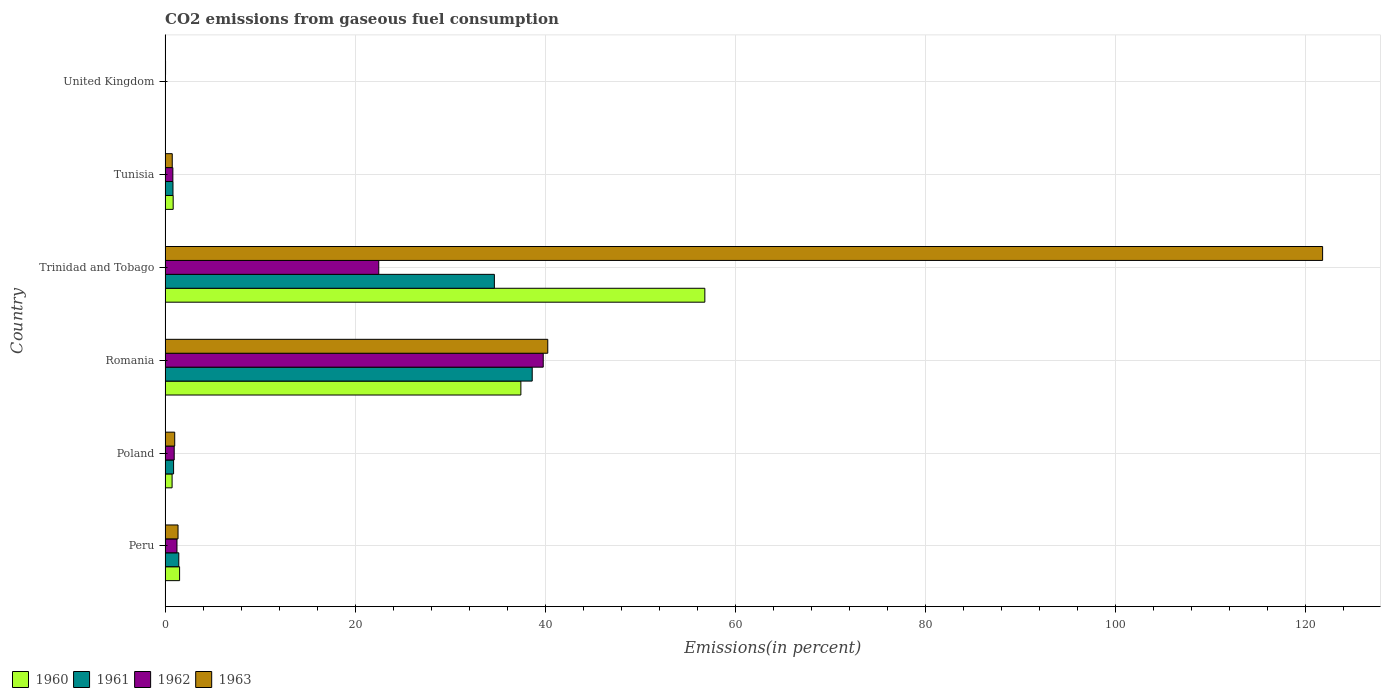How many groups of bars are there?
Your answer should be very brief. 6. How many bars are there on the 2nd tick from the top?
Offer a very short reply. 4. How many bars are there on the 4th tick from the bottom?
Provide a short and direct response. 4. What is the label of the 4th group of bars from the top?
Ensure brevity in your answer.  Romania. In how many cases, is the number of bars for a given country not equal to the number of legend labels?
Ensure brevity in your answer.  0. What is the total CO2 emitted in 1962 in United Kingdom?
Give a very brief answer. 0.04. Across all countries, what is the maximum total CO2 emitted in 1961?
Your response must be concise. 38.65. Across all countries, what is the minimum total CO2 emitted in 1960?
Provide a succinct answer. 0.03. In which country was the total CO2 emitted in 1962 maximum?
Ensure brevity in your answer.  Romania. In which country was the total CO2 emitted in 1962 minimum?
Provide a short and direct response. United Kingdom. What is the total total CO2 emitted in 1960 in the graph?
Your answer should be very brief. 97.41. What is the difference between the total CO2 emitted in 1960 in Peru and that in Poland?
Your answer should be compact. 0.79. What is the difference between the total CO2 emitted in 1963 in United Kingdom and the total CO2 emitted in 1961 in Peru?
Offer a terse response. -1.39. What is the average total CO2 emitted in 1963 per country?
Your response must be concise. 27.55. What is the difference between the total CO2 emitted in 1960 and total CO2 emitted in 1962 in Tunisia?
Offer a very short reply. 0.03. In how many countries, is the total CO2 emitted in 1960 greater than 28 %?
Offer a very short reply. 2. What is the ratio of the total CO2 emitted in 1962 in Peru to that in Tunisia?
Provide a short and direct response. 1.53. Is the difference between the total CO2 emitted in 1960 in Tunisia and United Kingdom greater than the difference between the total CO2 emitted in 1962 in Tunisia and United Kingdom?
Your answer should be very brief. Yes. What is the difference between the highest and the second highest total CO2 emitted in 1962?
Provide a short and direct response. 17.31. What is the difference between the highest and the lowest total CO2 emitted in 1963?
Ensure brevity in your answer.  121.8. Is it the case that in every country, the sum of the total CO2 emitted in 1960 and total CO2 emitted in 1962 is greater than the sum of total CO2 emitted in 1963 and total CO2 emitted in 1961?
Make the answer very short. No. What does the 4th bar from the top in Peru represents?
Make the answer very short. 1960. How many bars are there?
Give a very brief answer. 24. How many countries are there in the graph?
Offer a very short reply. 6. Does the graph contain any zero values?
Your answer should be very brief. No. Does the graph contain grids?
Keep it short and to the point. Yes. How are the legend labels stacked?
Provide a succinct answer. Horizontal. What is the title of the graph?
Your answer should be very brief. CO2 emissions from gaseous fuel consumption. What is the label or title of the X-axis?
Offer a terse response. Emissions(in percent). What is the Emissions(in percent) in 1960 in Peru?
Offer a terse response. 1.53. What is the Emissions(in percent) of 1961 in Peru?
Provide a succinct answer. 1.44. What is the Emissions(in percent) of 1962 in Peru?
Provide a short and direct response. 1.25. What is the Emissions(in percent) of 1963 in Peru?
Ensure brevity in your answer.  1.36. What is the Emissions(in percent) in 1960 in Poland?
Your response must be concise. 0.74. What is the Emissions(in percent) in 1961 in Poland?
Your answer should be very brief. 0.89. What is the Emissions(in percent) in 1962 in Poland?
Provide a short and direct response. 0.96. What is the Emissions(in percent) in 1963 in Poland?
Provide a short and direct response. 1.01. What is the Emissions(in percent) of 1960 in Romania?
Give a very brief answer. 37.45. What is the Emissions(in percent) of 1961 in Romania?
Your answer should be very brief. 38.65. What is the Emissions(in percent) in 1962 in Romania?
Offer a very short reply. 39.8. What is the Emissions(in percent) of 1963 in Romania?
Your response must be concise. 40.28. What is the Emissions(in percent) in 1960 in Trinidad and Tobago?
Offer a very short reply. 56.82. What is the Emissions(in percent) of 1961 in Trinidad and Tobago?
Ensure brevity in your answer.  34.66. What is the Emissions(in percent) of 1962 in Trinidad and Tobago?
Provide a short and direct response. 22.49. What is the Emissions(in percent) of 1963 in Trinidad and Tobago?
Offer a very short reply. 121.85. What is the Emissions(in percent) in 1960 in Tunisia?
Your response must be concise. 0.85. What is the Emissions(in percent) of 1961 in Tunisia?
Your response must be concise. 0.83. What is the Emissions(in percent) of 1962 in Tunisia?
Your answer should be compact. 0.82. What is the Emissions(in percent) in 1963 in Tunisia?
Provide a succinct answer. 0.75. What is the Emissions(in percent) in 1960 in United Kingdom?
Keep it short and to the point. 0.03. What is the Emissions(in percent) in 1961 in United Kingdom?
Provide a short and direct response. 0.03. What is the Emissions(in percent) of 1962 in United Kingdom?
Provide a short and direct response. 0.04. What is the Emissions(in percent) of 1963 in United Kingdom?
Keep it short and to the point. 0.05. Across all countries, what is the maximum Emissions(in percent) in 1960?
Offer a very short reply. 56.82. Across all countries, what is the maximum Emissions(in percent) in 1961?
Your response must be concise. 38.65. Across all countries, what is the maximum Emissions(in percent) of 1962?
Offer a terse response. 39.8. Across all countries, what is the maximum Emissions(in percent) of 1963?
Your answer should be very brief. 121.85. Across all countries, what is the minimum Emissions(in percent) in 1960?
Offer a very short reply. 0.03. Across all countries, what is the minimum Emissions(in percent) of 1961?
Your answer should be very brief. 0.03. Across all countries, what is the minimum Emissions(in percent) in 1962?
Keep it short and to the point. 0.04. Across all countries, what is the minimum Emissions(in percent) of 1963?
Your answer should be compact. 0.05. What is the total Emissions(in percent) in 1960 in the graph?
Ensure brevity in your answer.  97.41. What is the total Emissions(in percent) of 1961 in the graph?
Provide a succinct answer. 76.5. What is the total Emissions(in percent) of 1962 in the graph?
Offer a very short reply. 65.36. What is the total Emissions(in percent) of 1963 in the graph?
Make the answer very short. 165.31. What is the difference between the Emissions(in percent) of 1960 in Peru and that in Poland?
Keep it short and to the point. 0.79. What is the difference between the Emissions(in percent) of 1961 in Peru and that in Poland?
Offer a terse response. 0.55. What is the difference between the Emissions(in percent) of 1962 in Peru and that in Poland?
Offer a terse response. 0.29. What is the difference between the Emissions(in percent) of 1963 in Peru and that in Poland?
Make the answer very short. 0.35. What is the difference between the Emissions(in percent) of 1960 in Peru and that in Romania?
Keep it short and to the point. -35.93. What is the difference between the Emissions(in percent) in 1961 in Peru and that in Romania?
Offer a terse response. -37.2. What is the difference between the Emissions(in percent) of 1962 in Peru and that in Romania?
Ensure brevity in your answer.  -38.55. What is the difference between the Emissions(in percent) in 1963 in Peru and that in Romania?
Make the answer very short. -38.92. What is the difference between the Emissions(in percent) in 1960 in Peru and that in Trinidad and Tobago?
Your response must be concise. -55.29. What is the difference between the Emissions(in percent) of 1961 in Peru and that in Trinidad and Tobago?
Offer a very short reply. -33.22. What is the difference between the Emissions(in percent) of 1962 in Peru and that in Trinidad and Tobago?
Provide a short and direct response. -21.24. What is the difference between the Emissions(in percent) of 1963 in Peru and that in Trinidad and Tobago?
Give a very brief answer. -120.49. What is the difference between the Emissions(in percent) of 1960 in Peru and that in Tunisia?
Keep it short and to the point. 0.68. What is the difference between the Emissions(in percent) in 1961 in Peru and that in Tunisia?
Your answer should be compact. 0.61. What is the difference between the Emissions(in percent) in 1962 in Peru and that in Tunisia?
Provide a short and direct response. 0.43. What is the difference between the Emissions(in percent) in 1963 in Peru and that in Tunisia?
Provide a succinct answer. 0.61. What is the difference between the Emissions(in percent) of 1960 in Peru and that in United Kingdom?
Provide a short and direct response. 1.5. What is the difference between the Emissions(in percent) in 1961 in Peru and that in United Kingdom?
Make the answer very short. 1.42. What is the difference between the Emissions(in percent) in 1962 in Peru and that in United Kingdom?
Ensure brevity in your answer.  1.21. What is the difference between the Emissions(in percent) of 1963 in Peru and that in United Kingdom?
Give a very brief answer. 1.31. What is the difference between the Emissions(in percent) in 1960 in Poland and that in Romania?
Make the answer very short. -36.72. What is the difference between the Emissions(in percent) of 1961 in Poland and that in Romania?
Provide a short and direct response. -37.75. What is the difference between the Emissions(in percent) of 1962 in Poland and that in Romania?
Give a very brief answer. -38.85. What is the difference between the Emissions(in percent) of 1963 in Poland and that in Romania?
Make the answer very short. -39.27. What is the difference between the Emissions(in percent) in 1960 in Poland and that in Trinidad and Tobago?
Ensure brevity in your answer.  -56.08. What is the difference between the Emissions(in percent) of 1961 in Poland and that in Trinidad and Tobago?
Offer a terse response. -33.77. What is the difference between the Emissions(in percent) in 1962 in Poland and that in Trinidad and Tobago?
Provide a short and direct response. -21.53. What is the difference between the Emissions(in percent) of 1963 in Poland and that in Trinidad and Tobago?
Keep it short and to the point. -120.84. What is the difference between the Emissions(in percent) of 1960 in Poland and that in Tunisia?
Your response must be concise. -0.11. What is the difference between the Emissions(in percent) of 1961 in Poland and that in Tunisia?
Provide a short and direct response. 0.06. What is the difference between the Emissions(in percent) of 1962 in Poland and that in Tunisia?
Make the answer very short. 0.14. What is the difference between the Emissions(in percent) of 1963 in Poland and that in Tunisia?
Provide a succinct answer. 0.26. What is the difference between the Emissions(in percent) in 1960 in Poland and that in United Kingdom?
Keep it short and to the point. 0.71. What is the difference between the Emissions(in percent) of 1961 in Poland and that in United Kingdom?
Provide a short and direct response. 0.87. What is the difference between the Emissions(in percent) of 1962 in Poland and that in United Kingdom?
Provide a short and direct response. 0.92. What is the difference between the Emissions(in percent) of 1963 in Poland and that in United Kingdom?
Keep it short and to the point. 0.97. What is the difference between the Emissions(in percent) in 1960 in Romania and that in Trinidad and Tobago?
Offer a terse response. -19.37. What is the difference between the Emissions(in percent) in 1961 in Romania and that in Trinidad and Tobago?
Offer a very short reply. 3.98. What is the difference between the Emissions(in percent) in 1962 in Romania and that in Trinidad and Tobago?
Offer a very short reply. 17.31. What is the difference between the Emissions(in percent) in 1963 in Romania and that in Trinidad and Tobago?
Your answer should be compact. -81.57. What is the difference between the Emissions(in percent) of 1960 in Romania and that in Tunisia?
Provide a short and direct response. 36.6. What is the difference between the Emissions(in percent) in 1961 in Romania and that in Tunisia?
Make the answer very short. 37.82. What is the difference between the Emissions(in percent) in 1962 in Romania and that in Tunisia?
Offer a very short reply. 38.99. What is the difference between the Emissions(in percent) of 1963 in Romania and that in Tunisia?
Offer a terse response. 39.53. What is the difference between the Emissions(in percent) of 1960 in Romania and that in United Kingdom?
Offer a terse response. 37.43. What is the difference between the Emissions(in percent) of 1961 in Romania and that in United Kingdom?
Keep it short and to the point. 38.62. What is the difference between the Emissions(in percent) of 1962 in Romania and that in United Kingdom?
Ensure brevity in your answer.  39.77. What is the difference between the Emissions(in percent) of 1963 in Romania and that in United Kingdom?
Your response must be concise. 40.23. What is the difference between the Emissions(in percent) in 1960 in Trinidad and Tobago and that in Tunisia?
Give a very brief answer. 55.97. What is the difference between the Emissions(in percent) in 1961 in Trinidad and Tobago and that in Tunisia?
Make the answer very short. 33.83. What is the difference between the Emissions(in percent) of 1962 in Trinidad and Tobago and that in Tunisia?
Your response must be concise. 21.68. What is the difference between the Emissions(in percent) of 1963 in Trinidad and Tobago and that in Tunisia?
Provide a short and direct response. 121.1. What is the difference between the Emissions(in percent) in 1960 in Trinidad and Tobago and that in United Kingdom?
Provide a succinct answer. 56.79. What is the difference between the Emissions(in percent) in 1961 in Trinidad and Tobago and that in United Kingdom?
Make the answer very short. 34.64. What is the difference between the Emissions(in percent) of 1962 in Trinidad and Tobago and that in United Kingdom?
Your answer should be very brief. 22.46. What is the difference between the Emissions(in percent) of 1963 in Trinidad and Tobago and that in United Kingdom?
Keep it short and to the point. 121.8. What is the difference between the Emissions(in percent) of 1960 in Tunisia and that in United Kingdom?
Your response must be concise. 0.82. What is the difference between the Emissions(in percent) of 1961 in Tunisia and that in United Kingdom?
Give a very brief answer. 0.8. What is the difference between the Emissions(in percent) of 1962 in Tunisia and that in United Kingdom?
Provide a succinct answer. 0.78. What is the difference between the Emissions(in percent) in 1963 in Tunisia and that in United Kingdom?
Provide a short and direct response. 0.71. What is the difference between the Emissions(in percent) of 1960 in Peru and the Emissions(in percent) of 1961 in Poland?
Your response must be concise. 0.63. What is the difference between the Emissions(in percent) in 1960 in Peru and the Emissions(in percent) in 1962 in Poland?
Your response must be concise. 0.57. What is the difference between the Emissions(in percent) of 1960 in Peru and the Emissions(in percent) of 1963 in Poland?
Give a very brief answer. 0.51. What is the difference between the Emissions(in percent) in 1961 in Peru and the Emissions(in percent) in 1962 in Poland?
Your response must be concise. 0.48. What is the difference between the Emissions(in percent) of 1961 in Peru and the Emissions(in percent) of 1963 in Poland?
Offer a very short reply. 0.43. What is the difference between the Emissions(in percent) in 1962 in Peru and the Emissions(in percent) in 1963 in Poland?
Your response must be concise. 0.24. What is the difference between the Emissions(in percent) of 1960 in Peru and the Emissions(in percent) of 1961 in Romania?
Ensure brevity in your answer.  -37.12. What is the difference between the Emissions(in percent) of 1960 in Peru and the Emissions(in percent) of 1962 in Romania?
Provide a short and direct response. -38.28. What is the difference between the Emissions(in percent) of 1960 in Peru and the Emissions(in percent) of 1963 in Romania?
Provide a succinct answer. -38.76. What is the difference between the Emissions(in percent) of 1961 in Peru and the Emissions(in percent) of 1962 in Romania?
Your answer should be compact. -38.36. What is the difference between the Emissions(in percent) in 1961 in Peru and the Emissions(in percent) in 1963 in Romania?
Ensure brevity in your answer.  -38.84. What is the difference between the Emissions(in percent) in 1962 in Peru and the Emissions(in percent) in 1963 in Romania?
Ensure brevity in your answer.  -39.03. What is the difference between the Emissions(in percent) of 1960 in Peru and the Emissions(in percent) of 1961 in Trinidad and Tobago?
Your answer should be compact. -33.14. What is the difference between the Emissions(in percent) of 1960 in Peru and the Emissions(in percent) of 1962 in Trinidad and Tobago?
Provide a short and direct response. -20.97. What is the difference between the Emissions(in percent) in 1960 in Peru and the Emissions(in percent) in 1963 in Trinidad and Tobago?
Your response must be concise. -120.32. What is the difference between the Emissions(in percent) in 1961 in Peru and the Emissions(in percent) in 1962 in Trinidad and Tobago?
Offer a terse response. -21.05. What is the difference between the Emissions(in percent) of 1961 in Peru and the Emissions(in percent) of 1963 in Trinidad and Tobago?
Make the answer very short. -120.41. What is the difference between the Emissions(in percent) in 1962 in Peru and the Emissions(in percent) in 1963 in Trinidad and Tobago?
Offer a terse response. -120.6. What is the difference between the Emissions(in percent) in 1960 in Peru and the Emissions(in percent) in 1961 in Tunisia?
Give a very brief answer. 0.7. What is the difference between the Emissions(in percent) of 1960 in Peru and the Emissions(in percent) of 1962 in Tunisia?
Your answer should be compact. 0.71. What is the difference between the Emissions(in percent) in 1960 in Peru and the Emissions(in percent) in 1963 in Tunisia?
Offer a very short reply. 0.77. What is the difference between the Emissions(in percent) of 1961 in Peru and the Emissions(in percent) of 1962 in Tunisia?
Offer a very short reply. 0.63. What is the difference between the Emissions(in percent) of 1961 in Peru and the Emissions(in percent) of 1963 in Tunisia?
Provide a succinct answer. 0.69. What is the difference between the Emissions(in percent) of 1962 in Peru and the Emissions(in percent) of 1963 in Tunisia?
Make the answer very short. 0.5. What is the difference between the Emissions(in percent) of 1960 in Peru and the Emissions(in percent) of 1961 in United Kingdom?
Your answer should be very brief. 1.5. What is the difference between the Emissions(in percent) in 1960 in Peru and the Emissions(in percent) in 1962 in United Kingdom?
Make the answer very short. 1.49. What is the difference between the Emissions(in percent) of 1960 in Peru and the Emissions(in percent) of 1963 in United Kingdom?
Provide a short and direct response. 1.48. What is the difference between the Emissions(in percent) of 1961 in Peru and the Emissions(in percent) of 1962 in United Kingdom?
Your response must be concise. 1.41. What is the difference between the Emissions(in percent) of 1961 in Peru and the Emissions(in percent) of 1963 in United Kingdom?
Keep it short and to the point. 1.39. What is the difference between the Emissions(in percent) in 1962 in Peru and the Emissions(in percent) in 1963 in United Kingdom?
Give a very brief answer. 1.2. What is the difference between the Emissions(in percent) in 1960 in Poland and the Emissions(in percent) in 1961 in Romania?
Your answer should be compact. -37.91. What is the difference between the Emissions(in percent) in 1960 in Poland and the Emissions(in percent) in 1962 in Romania?
Offer a terse response. -39.07. What is the difference between the Emissions(in percent) of 1960 in Poland and the Emissions(in percent) of 1963 in Romania?
Offer a terse response. -39.55. What is the difference between the Emissions(in percent) in 1961 in Poland and the Emissions(in percent) in 1962 in Romania?
Your answer should be very brief. -38.91. What is the difference between the Emissions(in percent) in 1961 in Poland and the Emissions(in percent) in 1963 in Romania?
Keep it short and to the point. -39.39. What is the difference between the Emissions(in percent) of 1962 in Poland and the Emissions(in percent) of 1963 in Romania?
Ensure brevity in your answer.  -39.32. What is the difference between the Emissions(in percent) of 1960 in Poland and the Emissions(in percent) of 1961 in Trinidad and Tobago?
Offer a very short reply. -33.93. What is the difference between the Emissions(in percent) in 1960 in Poland and the Emissions(in percent) in 1962 in Trinidad and Tobago?
Offer a terse response. -21.76. What is the difference between the Emissions(in percent) in 1960 in Poland and the Emissions(in percent) in 1963 in Trinidad and Tobago?
Make the answer very short. -121.11. What is the difference between the Emissions(in percent) of 1961 in Poland and the Emissions(in percent) of 1962 in Trinidad and Tobago?
Your answer should be compact. -21.6. What is the difference between the Emissions(in percent) in 1961 in Poland and the Emissions(in percent) in 1963 in Trinidad and Tobago?
Your answer should be very brief. -120.95. What is the difference between the Emissions(in percent) of 1962 in Poland and the Emissions(in percent) of 1963 in Trinidad and Tobago?
Provide a succinct answer. -120.89. What is the difference between the Emissions(in percent) in 1960 in Poland and the Emissions(in percent) in 1961 in Tunisia?
Your response must be concise. -0.09. What is the difference between the Emissions(in percent) of 1960 in Poland and the Emissions(in percent) of 1962 in Tunisia?
Your response must be concise. -0.08. What is the difference between the Emissions(in percent) in 1960 in Poland and the Emissions(in percent) in 1963 in Tunisia?
Offer a very short reply. -0.02. What is the difference between the Emissions(in percent) in 1961 in Poland and the Emissions(in percent) in 1962 in Tunisia?
Provide a short and direct response. 0.08. What is the difference between the Emissions(in percent) in 1961 in Poland and the Emissions(in percent) in 1963 in Tunisia?
Provide a short and direct response. 0.14. What is the difference between the Emissions(in percent) of 1962 in Poland and the Emissions(in percent) of 1963 in Tunisia?
Your response must be concise. 0.21. What is the difference between the Emissions(in percent) in 1960 in Poland and the Emissions(in percent) in 1961 in United Kingdom?
Ensure brevity in your answer.  0.71. What is the difference between the Emissions(in percent) of 1960 in Poland and the Emissions(in percent) of 1962 in United Kingdom?
Offer a very short reply. 0.7. What is the difference between the Emissions(in percent) in 1960 in Poland and the Emissions(in percent) in 1963 in United Kingdom?
Make the answer very short. 0.69. What is the difference between the Emissions(in percent) in 1961 in Poland and the Emissions(in percent) in 1962 in United Kingdom?
Your answer should be compact. 0.86. What is the difference between the Emissions(in percent) of 1961 in Poland and the Emissions(in percent) of 1963 in United Kingdom?
Offer a very short reply. 0.85. What is the difference between the Emissions(in percent) in 1962 in Poland and the Emissions(in percent) in 1963 in United Kingdom?
Keep it short and to the point. 0.91. What is the difference between the Emissions(in percent) in 1960 in Romania and the Emissions(in percent) in 1961 in Trinidad and Tobago?
Give a very brief answer. 2.79. What is the difference between the Emissions(in percent) of 1960 in Romania and the Emissions(in percent) of 1962 in Trinidad and Tobago?
Provide a short and direct response. 14.96. What is the difference between the Emissions(in percent) of 1960 in Romania and the Emissions(in percent) of 1963 in Trinidad and Tobago?
Your answer should be very brief. -84.4. What is the difference between the Emissions(in percent) of 1961 in Romania and the Emissions(in percent) of 1962 in Trinidad and Tobago?
Provide a succinct answer. 16.15. What is the difference between the Emissions(in percent) of 1961 in Romania and the Emissions(in percent) of 1963 in Trinidad and Tobago?
Offer a very short reply. -83.2. What is the difference between the Emissions(in percent) in 1962 in Romania and the Emissions(in percent) in 1963 in Trinidad and Tobago?
Ensure brevity in your answer.  -82.04. What is the difference between the Emissions(in percent) of 1960 in Romania and the Emissions(in percent) of 1961 in Tunisia?
Offer a terse response. 36.62. What is the difference between the Emissions(in percent) of 1960 in Romania and the Emissions(in percent) of 1962 in Tunisia?
Your answer should be compact. 36.64. What is the difference between the Emissions(in percent) in 1960 in Romania and the Emissions(in percent) in 1963 in Tunisia?
Ensure brevity in your answer.  36.7. What is the difference between the Emissions(in percent) in 1961 in Romania and the Emissions(in percent) in 1962 in Tunisia?
Offer a very short reply. 37.83. What is the difference between the Emissions(in percent) of 1961 in Romania and the Emissions(in percent) of 1963 in Tunisia?
Provide a short and direct response. 37.89. What is the difference between the Emissions(in percent) in 1962 in Romania and the Emissions(in percent) in 1963 in Tunisia?
Keep it short and to the point. 39.05. What is the difference between the Emissions(in percent) in 1960 in Romania and the Emissions(in percent) in 1961 in United Kingdom?
Make the answer very short. 37.43. What is the difference between the Emissions(in percent) of 1960 in Romania and the Emissions(in percent) of 1962 in United Kingdom?
Give a very brief answer. 37.42. What is the difference between the Emissions(in percent) in 1960 in Romania and the Emissions(in percent) in 1963 in United Kingdom?
Make the answer very short. 37.4. What is the difference between the Emissions(in percent) in 1961 in Romania and the Emissions(in percent) in 1962 in United Kingdom?
Provide a succinct answer. 38.61. What is the difference between the Emissions(in percent) in 1961 in Romania and the Emissions(in percent) in 1963 in United Kingdom?
Offer a terse response. 38.6. What is the difference between the Emissions(in percent) in 1962 in Romania and the Emissions(in percent) in 1963 in United Kingdom?
Ensure brevity in your answer.  39.76. What is the difference between the Emissions(in percent) of 1960 in Trinidad and Tobago and the Emissions(in percent) of 1961 in Tunisia?
Make the answer very short. 55.99. What is the difference between the Emissions(in percent) of 1960 in Trinidad and Tobago and the Emissions(in percent) of 1962 in Tunisia?
Make the answer very short. 56. What is the difference between the Emissions(in percent) in 1960 in Trinidad and Tobago and the Emissions(in percent) in 1963 in Tunisia?
Offer a very short reply. 56.06. What is the difference between the Emissions(in percent) in 1961 in Trinidad and Tobago and the Emissions(in percent) in 1962 in Tunisia?
Your response must be concise. 33.84. What is the difference between the Emissions(in percent) in 1961 in Trinidad and Tobago and the Emissions(in percent) in 1963 in Tunisia?
Ensure brevity in your answer.  33.91. What is the difference between the Emissions(in percent) in 1962 in Trinidad and Tobago and the Emissions(in percent) in 1963 in Tunisia?
Ensure brevity in your answer.  21.74. What is the difference between the Emissions(in percent) in 1960 in Trinidad and Tobago and the Emissions(in percent) in 1961 in United Kingdom?
Offer a terse response. 56.79. What is the difference between the Emissions(in percent) in 1960 in Trinidad and Tobago and the Emissions(in percent) in 1962 in United Kingdom?
Offer a very short reply. 56.78. What is the difference between the Emissions(in percent) in 1960 in Trinidad and Tobago and the Emissions(in percent) in 1963 in United Kingdom?
Make the answer very short. 56.77. What is the difference between the Emissions(in percent) of 1961 in Trinidad and Tobago and the Emissions(in percent) of 1962 in United Kingdom?
Give a very brief answer. 34.62. What is the difference between the Emissions(in percent) of 1961 in Trinidad and Tobago and the Emissions(in percent) of 1963 in United Kingdom?
Your answer should be compact. 34.61. What is the difference between the Emissions(in percent) of 1962 in Trinidad and Tobago and the Emissions(in percent) of 1963 in United Kingdom?
Provide a succinct answer. 22.44. What is the difference between the Emissions(in percent) of 1960 in Tunisia and the Emissions(in percent) of 1961 in United Kingdom?
Provide a short and direct response. 0.82. What is the difference between the Emissions(in percent) of 1960 in Tunisia and the Emissions(in percent) of 1962 in United Kingdom?
Your answer should be compact. 0.81. What is the difference between the Emissions(in percent) of 1960 in Tunisia and the Emissions(in percent) of 1963 in United Kingdom?
Offer a very short reply. 0.8. What is the difference between the Emissions(in percent) in 1961 in Tunisia and the Emissions(in percent) in 1962 in United Kingdom?
Offer a terse response. 0.79. What is the difference between the Emissions(in percent) of 1961 in Tunisia and the Emissions(in percent) of 1963 in United Kingdom?
Your answer should be compact. 0.78. What is the difference between the Emissions(in percent) in 1962 in Tunisia and the Emissions(in percent) in 1963 in United Kingdom?
Your answer should be compact. 0.77. What is the average Emissions(in percent) of 1960 per country?
Keep it short and to the point. 16.23. What is the average Emissions(in percent) in 1961 per country?
Offer a terse response. 12.75. What is the average Emissions(in percent) of 1962 per country?
Give a very brief answer. 10.89. What is the average Emissions(in percent) of 1963 per country?
Keep it short and to the point. 27.55. What is the difference between the Emissions(in percent) in 1960 and Emissions(in percent) in 1961 in Peru?
Offer a terse response. 0.08. What is the difference between the Emissions(in percent) of 1960 and Emissions(in percent) of 1962 in Peru?
Your answer should be very brief. 0.27. What is the difference between the Emissions(in percent) in 1960 and Emissions(in percent) in 1963 in Peru?
Ensure brevity in your answer.  0.16. What is the difference between the Emissions(in percent) of 1961 and Emissions(in percent) of 1962 in Peru?
Make the answer very short. 0.19. What is the difference between the Emissions(in percent) in 1961 and Emissions(in percent) in 1963 in Peru?
Provide a short and direct response. 0.08. What is the difference between the Emissions(in percent) in 1962 and Emissions(in percent) in 1963 in Peru?
Give a very brief answer. -0.11. What is the difference between the Emissions(in percent) of 1960 and Emissions(in percent) of 1961 in Poland?
Offer a very short reply. -0.16. What is the difference between the Emissions(in percent) of 1960 and Emissions(in percent) of 1962 in Poland?
Offer a very short reply. -0.22. What is the difference between the Emissions(in percent) in 1960 and Emissions(in percent) in 1963 in Poland?
Your answer should be very brief. -0.28. What is the difference between the Emissions(in percent) of 1961 and Emissions(in percent) of 1962 in Poland?
Keep it short and to the point. -0.06. What is the difference between the Emissions(in percent) in 1961 and Emissions(in percent) in 1963 in Poland?
Offer a terse response. -0.12. What is the difference between the Emissions(in percent) in 1962 and Emissions(in percent) in 1963 in Poland?
Your answer should be very brief. -0.05. What is the difference between the Emissions(in percent) in 1960 and Emissions(in percent) in 1961 in Romania?
Provide a succinct answer. -1.19. What is the difference between the Emissions(in percent) in 1960 and Emissions(in percent) in 1962 in Romania?
Offer a very short reply. -2.35. What is the difference between the Emissions(in percent) in 1960 and Emissions(in percent) in 1963 in Romania?
Your answer should be compact. -2.83. What is the difference between the Emissions(in percent) in 1961 and Emissions(in percent) in 1962 in Romania?
Make the answer very short. -1.16. What is the difference between the Emissions(in percent) of 1961 and Emissions(in percent) of 1963 in Romania?
Offer a terse response. -1.64. What is the difference between the Emissions(in percent) of 1962 and Emissions(in percent) of 1963 in Romania?
Make the answer very short. -0.48. What is the difference between the Emissions(in percent) of 1960 and Emissions(in percent) of 1961 in Trinidad and Tobago?
Provide a succinct answer. 22.16. What is the difference between the Emissions(in percent) of 1960 and Emissions(in percent) of 1962 in Trinidad and Tobago?
Your answer should be compact. 34.33. What is the difference between the Emissions(in percent) in 1960 and Emissions(in percent) in 1963 in Trinidad and Tobago?
Make the answer very short. -65.03. What is the difference between the Emissions(in percent) in 1961 and Emissions(in percent) in 1962 in Trinidad and Tobago?
Offer a very short reply. 12.17. What is the difference between the Emissions(in percent) of 1961 and Emissions(in percent) of 1963 in Trinidad and Tobago?
Offer a terse response. -87.19. What is the difference between the Emissions(in percent) in 1962 and Emissions(in percent) in 1963 in Trinidad and Tobago?
Provide a short and direct response. -99.36. What is the difference between the Emissions(in percent) in 1960 and Emissions(in percent) in 1961 in Tunisia?
Ensure brevity in your answer.  0.02. What is the difference between the Emissions(in percent) in 1960 and Emissions(in percent) in 1962 in Tunisia?
Offer a terse response. 0.03. What is the difference between the Emissions(in percent) of 1960 and Emissions(in percent) of 1963 in Tunisia?
Your answer should be very brief. 0.1. What is the difference between the Emissions(in percent) of 1961 and Emissions(in percent) of 1962 in Tunisia?
Offer a very short reply. 0.01. What is the difference between the Emissions(in percent) of 1961 and Emissions(in percent) of 1963 in Tunisia?
Your response must be concise. 0.08. What is the difference between the Emissions(in percent) of 1962 and Emissions(in percent) of 1963 in Tunisia?
Your response must be concise. 0.06. What is the difference between the Emissions(in percent) of 1960 and Emissions(in percent) of 1962 in United Kingdom?
Give a very brief answer. -0.01. What is the difference between the Emissions(in percent) in 1960 and Emissions(in percent) in 1963 in United Kingdom?
Give a very brief answer. -0.02. What is the difference between the Emissions(in percent) of 1961 and Emissions(in percent) of 1962 in United Kingdom?
Keep it short and to the point. -0.01. What is the difference between the Emissions(in percent) in 1961 and Emissions(in percent) in 1963 in United Kingdom?
Your answer should be compact. -0.02. What is the difference between the Emissions(in percent) of 1962 and Emissions(in percent) of 1963 in United Kingdom?
Give a very brief answer. -0.01. What is the ratio of the Emissions(in percent) of 1960 in Peru to that in Poland?
Ensure brevity in your answer.  2.07. What is the ratio of the Emissions(in percent) of 1961 in Peru to that in Poland?
Offer a very short reply. 1.61. What is the ratio of the Emissions(in percent) of 1962 in Peru to that in Poland?
Your answer should be compact. 1.3. What is the ratio of the Emissions(in percent) in 1963 in Peru to that in Poland?
Your answer should be very brief. 1.34. What is the ratio of the Emissions(in percent) in 1960 in Peru to that in Romania?
Provide a succinct answer. 0.04. What is the ratio of the Emissions(in percent) in 1961 in Peru to that in Romania?
Provide a short and direct response. 0.04. What is the ratio of the Emissions(in percent) of 1962 in Peru to that in Romania?
Your answer should be compact. 0.03. What is the ratio of the Emissions(in percent) of 1963 in Peru to that in Romania?
Ensure brevity in your answer.  0.03. What is the ratio of the Emissions(in percent) of 1960 in Peru to that in Trinidad and Tobago?
Keep it short and to the point. 0.03. What is the ratio of the Emissions(in percent) in 1961 in Peru to that in Trinidad and Tobago?
Offer a very short reply. 0.04. What is the ratio of the Emissions(in percent) of 1962 in Peru to that in Trinidad and Tobago?
Provide a succinct answer. 0.06. What is the ratio of the Emissions(in percent) of 1963 in Peru to that in Trinidad and Tobago?
Ensure brevity in your answer.  0.01. What is the ratio of the Emissions(in percent) of 1960 in Peru to that in Tunisia?
Provide a short and direct response. 1.8. What is the ratio of the Emissions(in percent) in 1961 in Peru to that in Tunisia?
Your answer should be compact. 1.74. What is the ratio of the Emissions(in percent) in 1962 in Peru to that in Tunisia?
Make the answer very short. 1.53. What is the ratio of the Emissions(in percent) in 1963 in Peru to that in Tunisia?
Offer a terse response. 1.81. What is the ratio of the Emissions(in percent) of 1960 in Peru to that in United Kingdom?
Your answer should be compact. 59.28. What is the ratio of the Emissions(in percent) of 1961 in Peru to that in United Kingdom?
Keep it short and to the point. 56.51. What is the ratio of the Emissions(in percent) of 1962 in Peru to that in United Kingdom?
Provide a short and direct response. 34.29. What is the ratio of the Emissions(in percent) in 1963 in Peru to that in United Kingdom?
Your answer should be compact. 28.38. What is the ratio of the Emissions(in percent) in 1960 in Poland to that in Romania?
Provide a short and direct response. 0.02. What is the ratio of the Emissions(in percent) of 1961 in Poland to that in Romania?
Offer a terse response. 0.02. What is the ratio of the Emissions(in percent) of 1962 in Poland to that in Romania?
Provide a short and direct response. 0.02. What is the ratio of the Emissions(in percent) in 1963 in Poland to that in Romania?
Ensure brevity in your answer.  0.03. What is the ratio of the Emissions(in percent) of 1960 in Poland to that in Trinidad and Tobago?
Your answer should be compact. 0.01. What is the ratio of the Emissions(in percent) of 1961 in Poland to that in Trinidad and Tobago?
Your response must be concise. 0.03. What is the ratio of the Emissions(in percent) in 1962 in Poland to that in Trinidad and Tobago?
Ensure brevity in your answer.  0.04. What is the ratio of the Emissions(in percent) in 1963 in Poland to that in Trinidad and Tobago?
Offer a very short reply. 0.01. What is the ratio of the Emissions(in percent) in 1960 in Poland to that in Tunisia?
Offer a very short reply. 0.87. What is the ratio of the Emissions(in percent) of 1961 in Poland to that in Tunisia?
Offer a very short reply. 1.08. What is the ratio of the Emissions(in percent) of 1962 in Poland to that in Tunisia?
Offer a very short reply. 1.17. What is the ratio of the Emissions(in percent) of 1963 in Poland to that in Tunisia?
Offer a terse response. 1.35. What is the ratio of the Emissions(in percent) of 1960 in Poland to that in United Kingdom?
Offer a very short reply. 28.61. What is the ratio of the Emissions(in percent) in 1961 in Poland to that in United Kingdom?
Ensure brevity in your answer.  35.04. What is the ratio of the Emissions(in percent) in 1962 in Poland to that in United Kingdom?
Provide a succinct answer. 26.3. What is the ratio of the Emissions(in percent) in 1963 in Poland to that in United Kingdom?
Provide a succinct answer. 21.12. What is the ratio of the Emissions(in percent) of 1960 in Romania to that in Trinidad and Tobago?
Offer a terse response. 0.66. What is the ratio of the Emissions(in percent) in 1961 in Romania to that in Trinidad and Tobago?
Your answer should be compact. 1.11. What is the ratio of the Emissions(in percent) in 1962 in Romania to that in Trinidad and Tobago?
Give a very brief answer. 1.77. What is the ratio of the Emissions(in percent) of 1963 in Romania to that in Trinidad and Tobago?
Provide a succinct answer. 0.33. What is the ratio of the Emissions(in percent) in 1960 in Romania to that in Tunisia?
Keep it short and to the point. 44.1. What is the ratio of the Emissions(in percent) in 1961 in Romania to that in Tunisia?
Your answer should be compact. 46.57. What is the ratio of the Emissions(in percent) in 1962 in Romania to that in Tunisia?
Offer a very short reply. 48.76. What is the ratio of the Emissions(in percent) of 1963 in Romania to that in Tunisia?
Your response must be concise. 53.48. What is the ratio of the Emissions(in percent) of 1960 in Romania to that in United Kingdom?
Offer a very short reply. 1455.51. What is the ratio of the Emissions(in percent) of 1961 in Romania to that in United Kingdom?
Provide a succinct answer. 1513.82. What is the ratio of the Emissions(in percent) in 1962 in Romania to that in United Kingdom?
Give a very brief answer. 1091.67. What is the ratio of the Emissions(in percent) in 1963 in Romania to that in United Kingdom?
Give a very brief answer. 839.63. What is the ratio of the Emissions(in percent) of 1960 in Trinidad and Tobago to that in Tunisia?
Offer a very short reply. 66.9. What is the ratio of the Emissions(in percent) of 1961 in Trinidad and Tobago to that in Tunisia?
Offer a very short reply. 41.77. What is the ratio of the Emissions(in percent) of 1962 in Trinidad and Tobago to that in Tunisia?
Your answer should be compact. 27.55. What is the ratio of the Emissions(in percent) of 1963 in Trinidad and Tobago to that in Tunisia?
Give a very brief answer. 161.75. What is the ratio of the Emissions(in percent) of 1960 in Trinidad and Tobago to that in United Kingdom?
Provide a short and direct response. 2208.15. What is the ratio of the Emissions(in percent) of 1961 in Trinidad and Tobago to that in United Kingdom?
Provide a short and direct response. 1357.75. What is the ratio of the Emissions(in percent) of 1962 in Trinidad and Tobago to that in United Kingdom?
Keep it short and to the point. 616.87. What is the ratio of the Emissions(in percent) of 1963 in Trinidad and Tobago to that in United Kingdom?
Provide a succinct answer. 2539.76. What is the ratio of the Emissions(in percent) in 1960 in Tunisia to that in United Kingdom?
Offer a very short reply. 33.01. What is the ratio of the Emissions(in percent) in 1961 in Tunisia to that in United Kingdom?
Offer a very short reply. 32.51. What is the ratio of the Emissions(in percent) in 1962 in Tunisia to that in United Kingdom?
Your answer should be very brief. 22.39. What is the ratio of the Emissions(in percent) of 1963 in Tunisia to that in United Kingdom?
Ensure brevity in your answer.  15.7. What is the difference between the highest and the second highest Emissions(in percent) in 1960?
Keep it short and to the point. 19.37. What is the difference between the highest and the second highest Emissions(in percent) of 1961?
Your answer should be very brief. 3.98. What is the difference between the highest and the second highest Emissions(in percent) of 1962?
Your answer should be compact. 17.31. What is the difference between the highest and the second highest Emissions(in percent) in 1963?
Make the answer very short. 81.57. What is the difference between the highest and the lowest Emissions(in percent) in 1960?
Keep it short and to the point. 56.79. What is the difference between the highest and the lowest Emissions(in percent) of 1961?
Ensure brevity in your answer.  38.62. What is the difference between the highest and the lowest Emissions(in percent) of 1962?
Provide a short and direct response. 39.77. What is the difference between the highest and the lowest Emissions(in percent) in 1963?
Ensure brevity in your answer.  121.8. 